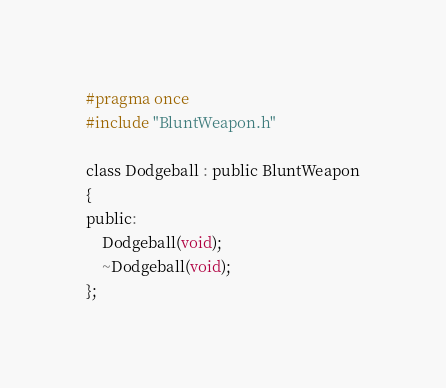Convert code to text. <code><loc_0><loc_0><loc_500><loc_500><_C_>#pragma once
#include "BluntWeapon.h"

class Dodgeball : public BluntWeapon
{
public:
	Dodgeball(void);
	~Dodgeball(void);
};</code> 